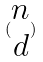Convert formula to latex. <formula><loc_0><loc_0><loc_500><loc_500>( \begin{matrix} n \\ d \end{matrix} )</formula> 